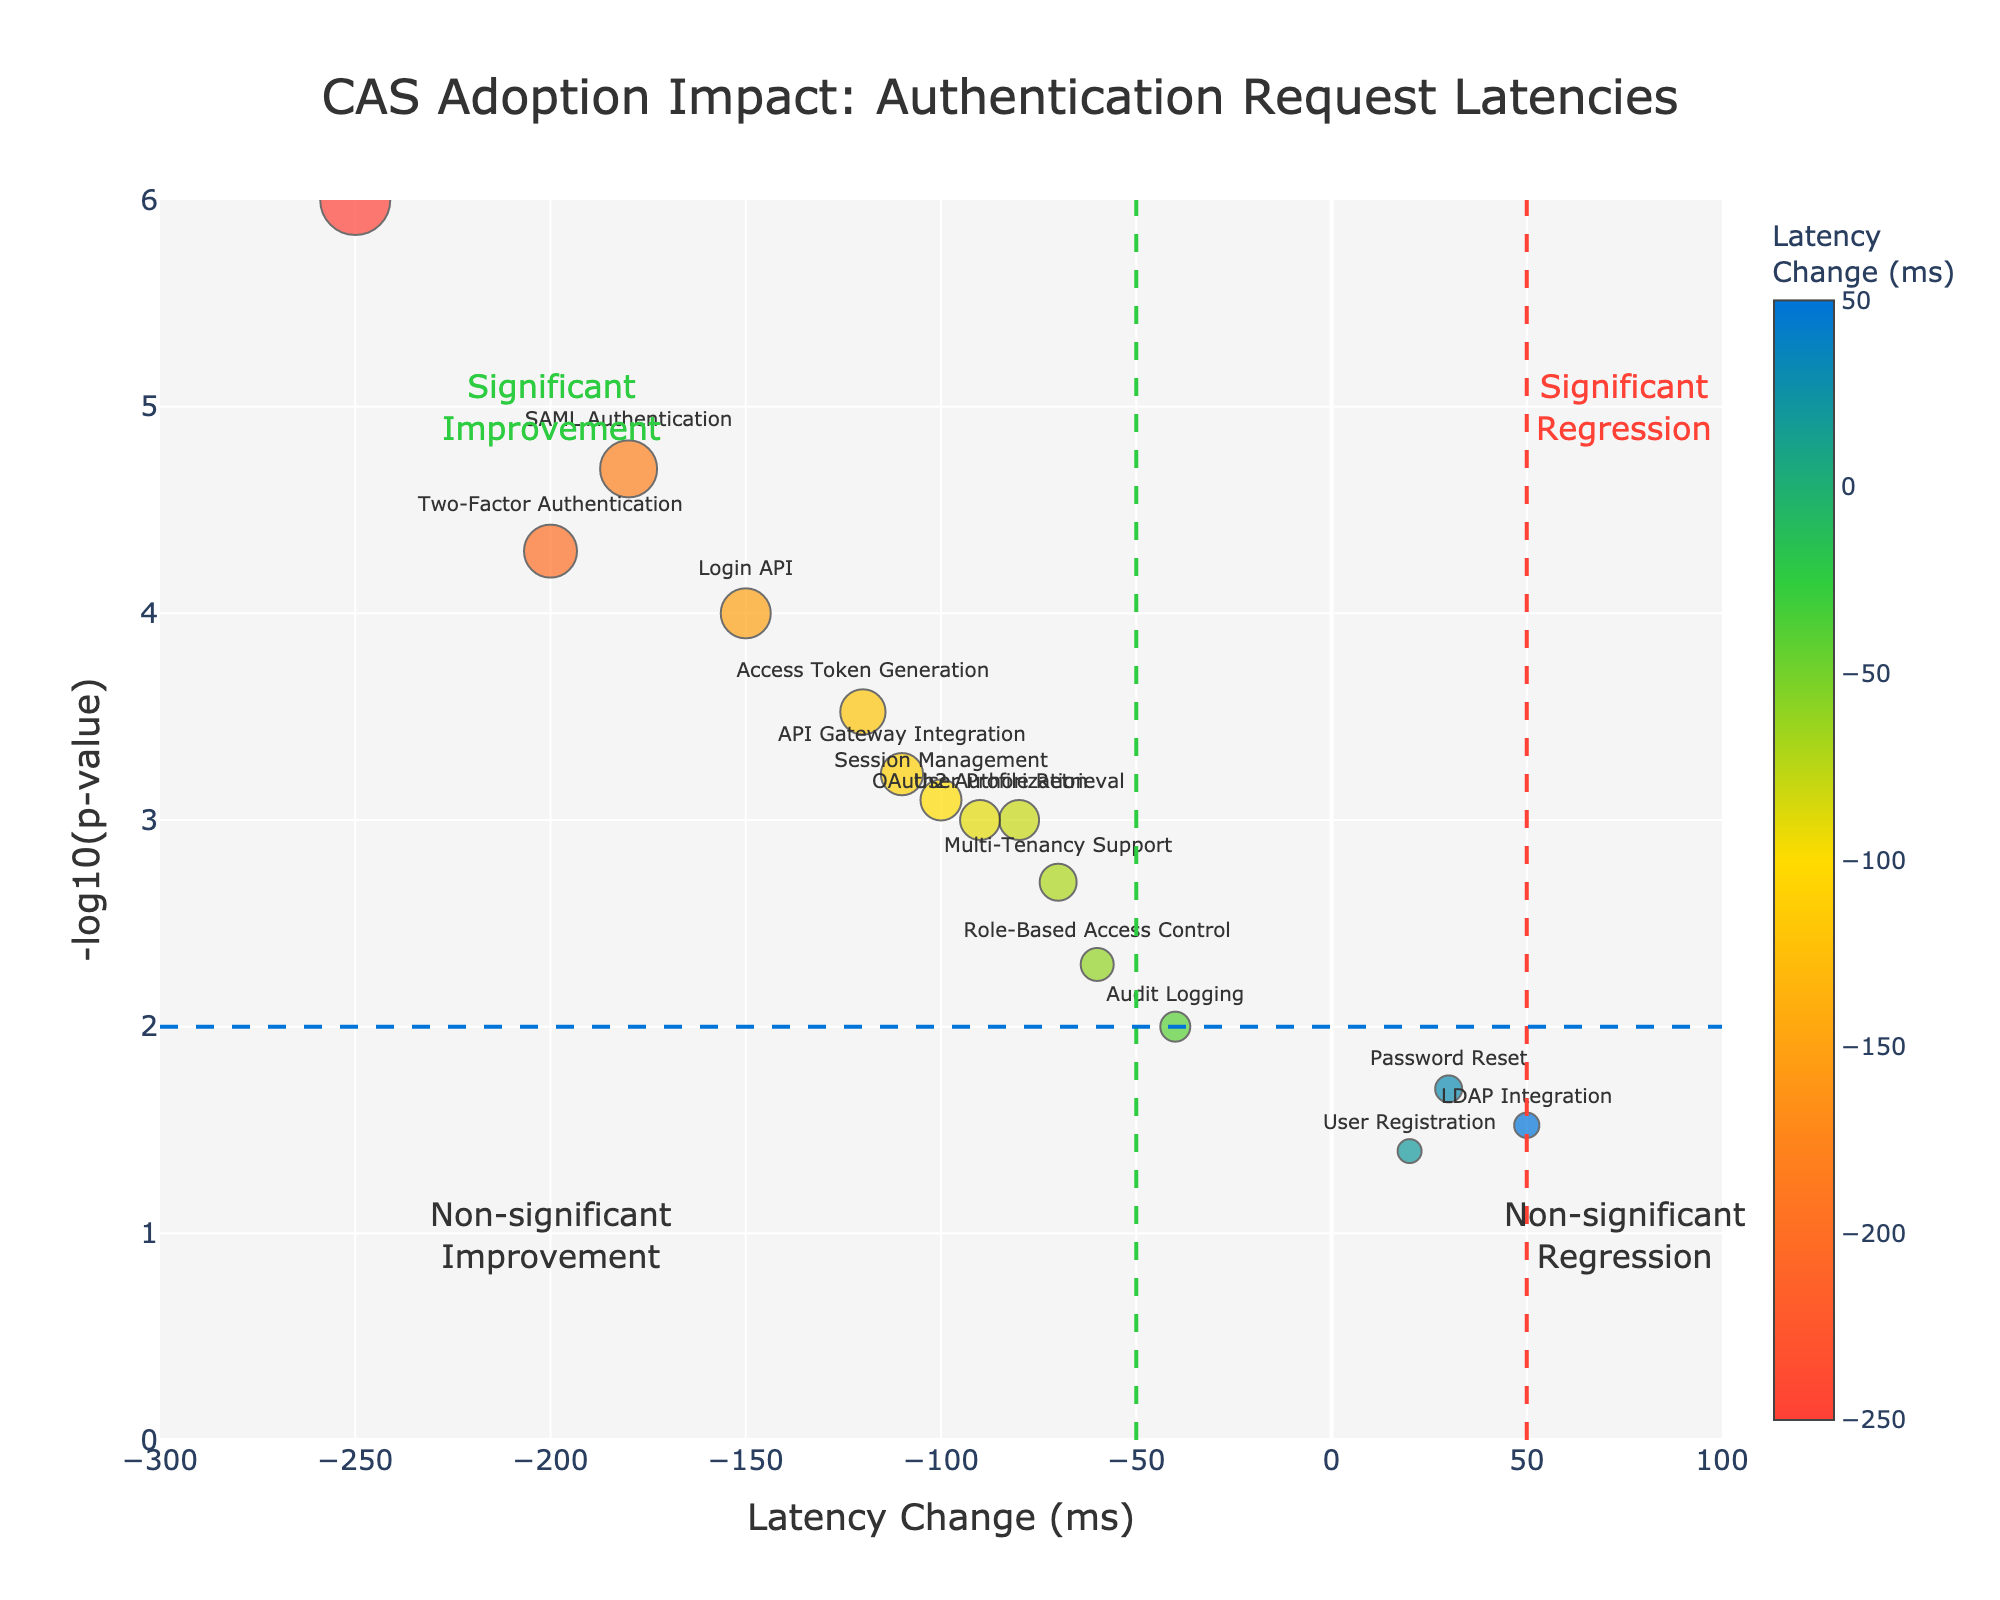What's the title of the plot? To find the title, look at the top of the plot where the text is aligned at the center. The title usually provides an overview of the plot's purpose.
Answer: CAS Adoption Impact: Authentication Request Latencies What's the range of the x-axis? The range of the x-axis can be determined by looking at the minimum and maximum values marked on the axis at the bottom of the plot.
Answer: -300 to 100 Which service has the most significant improvement in latency? Look for the service with the lowest latency change value (most negative), which indicates the greatest improvement. The text annotations identify each service.
Answer: Single Sign-On How many authentication requests show significant improvement? Count the number of data points (services) that fall to the left of the latency threshold line (-50 ms) and above the p-value threshold line (-log10(p-value) > 2).
Answer: 9 Which services show significant regression? Identify the data points to the right of the positive latency threshold line (50 ms) and above the p-value threshold line (-log10(p-value) > 2). The text annotations will indicate the services.
Answer: Password Reset, LDAP Integration, User Registration What is the p-value threshold represented on the y-axis? Look for the horizontal dashed line and its corresponding y-axis value, which marks the p-value threshold. This line helps differentiate significant from non-significant changes.
Answer: 0.01 How is the latency change of the Login API compared to that of the Access Token Generation? Identify the latency change values for both services and compare them. The Login API has a latency change of -150 ms, and Access Token Generation has a latency change of -120 ms. Thus, the Login API has a greater reduction in latency.
Answer: Login API has a greater reduction in latency Which quadrant has the most data points for services with non-significant changes? Non-significant changes are below the p-value threshold line. Count the data points in the two corresponding quadrants (positive and negative latency changes).
Answer: Non-significant improvements Is there any service with a p-value below 0.0001 but a positive latency change? To determine this, look for data points with positive latency changes (right of the center vertical axis) and a -log10(p-value) greater than 4. The hovertext and text annotations will help identify these services.
Answer: No What is the latency change and p-value for the Two-Factor Authentication service? Identify the point annotated with "Two-Factor Authentication" and refer to the hovertext or the point on the plot to get its values.
Answer: Latency change: -200 ms, p-value: 0.00005 